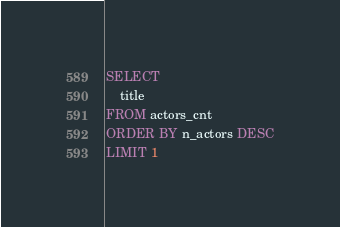<code> <loc_0><loc_0><loc_500><loc_500><_SQL_>SELECT 
	title
FROM actors_cnt
ORDER BY n_actors DESC
LIMIT 1</code> 